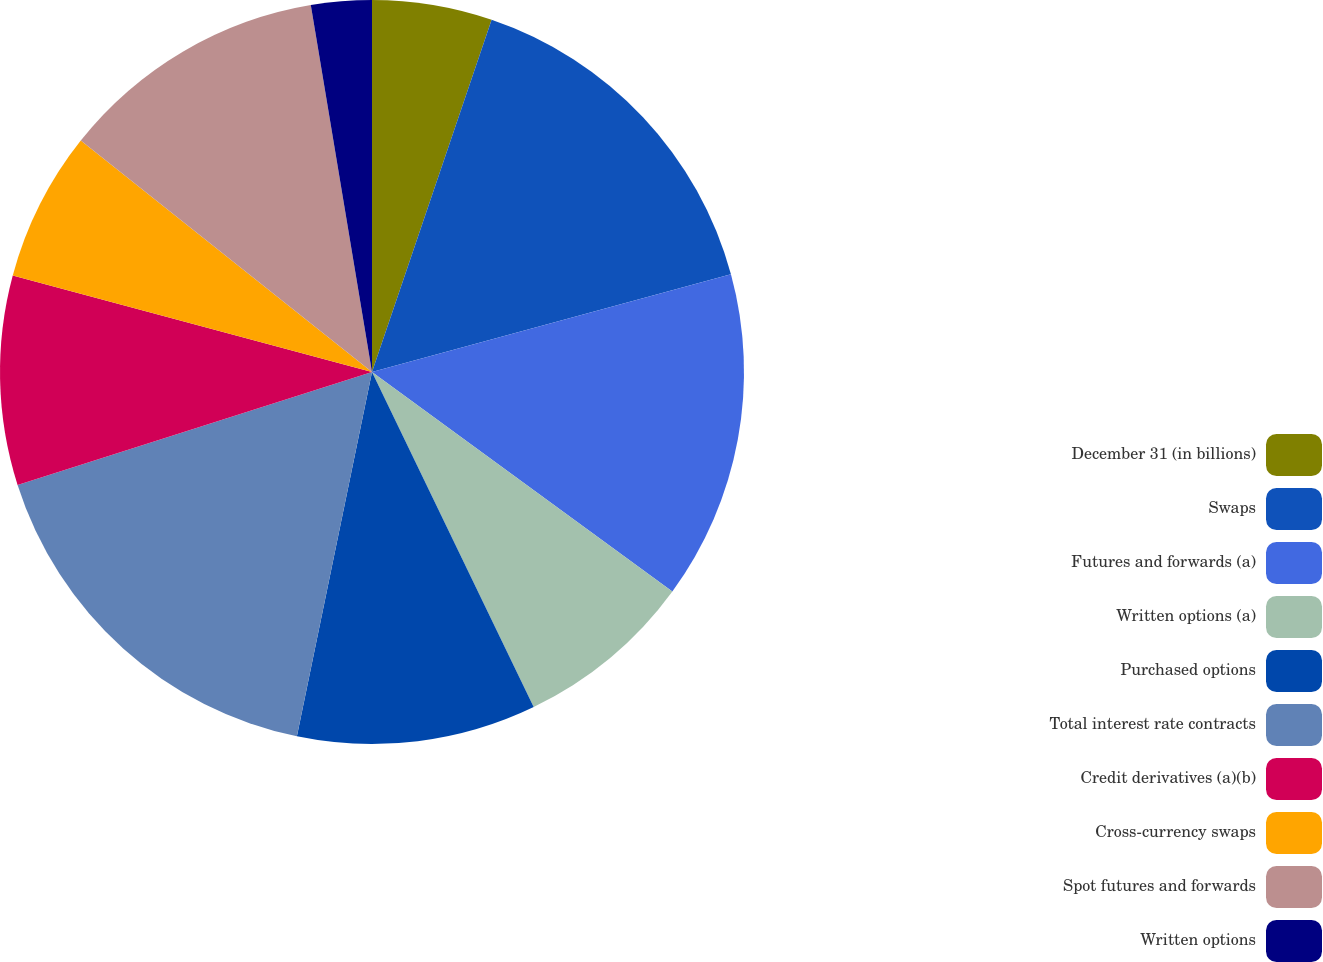Convert chart. <chart><loc_0><loc_0><loc_500><loc_500><pie_chart><fcel>December 31 (in billions)<fcel>Swaps<fcel>Futures and forwards (a)<fcel>Written options (a)<fcel>Purchased options<fcel>Total interest rate contracts<fcel>Credit derivatives (a)(b)<fcel>Cross-currency swaps<fcel>Spot futures and forwards<fcel>Written options<nl><fcel>5.21%<fcel>15.56%<fcel>14.27%<fcel>7.8%<fcel>10.39%<fcel>16.85%<fcel>9.09%<fcel>6.51%<fcel>11.68%<fcel>2.63%<nl></chart> 